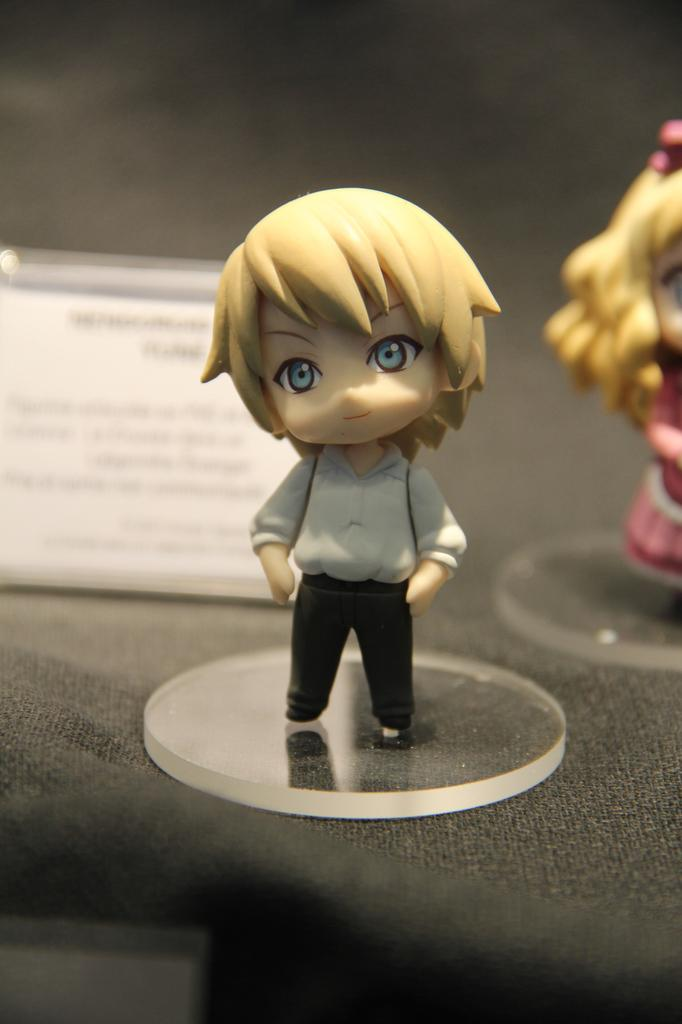What type of objects can be seen in the image? There are toys in the image. Is there any additional information provided in the image? Yes, there is a description board in the image. Can you describe the object at the bottom of the image? Unfortunately, the facts provided do not give enough information to describe the object at the bottom of the image. How many sheep are visible in the image? There are no sheep present in the image. What type of behavior is exhibited by the toys in the image? The toys in the image are inanimate objects and do not exhibit any behavior. 